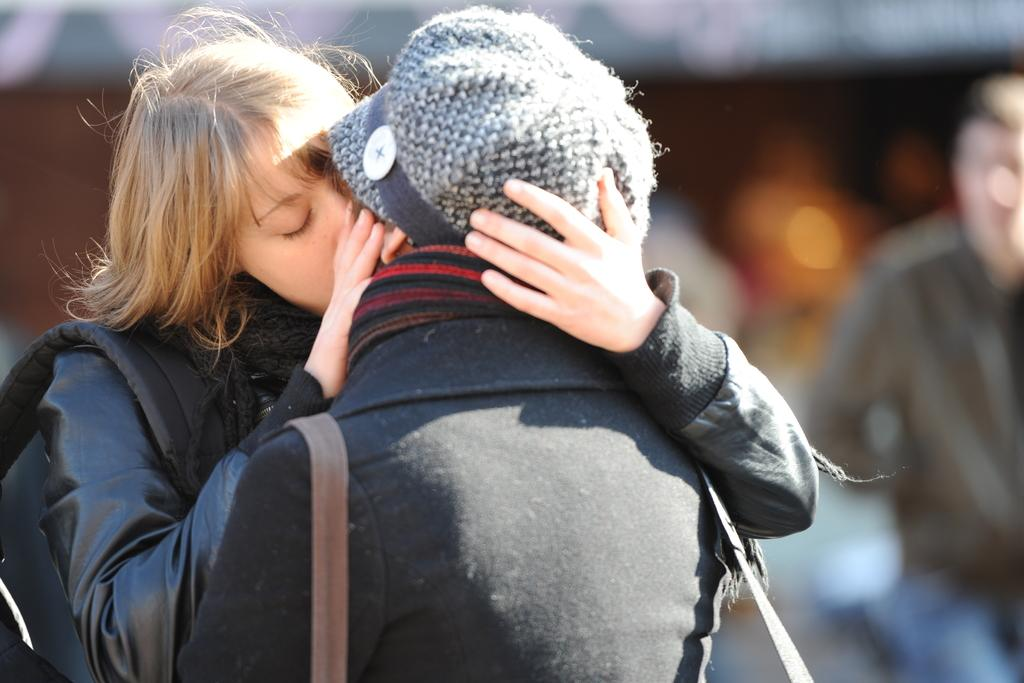How many people are present in the image? There are two people in the image. What are the two people doing in the image? The two people are kissing each other. Can you describe the background of the image? The background of the people is blurred. What type of collar can be seen on the women in the image? There are no women present in the image, and no collars are visible. 